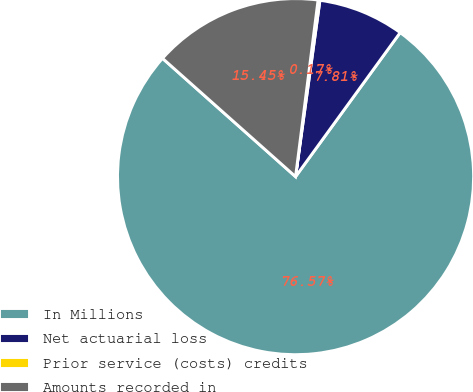Convert chart. <chart><loc_0><loc_0><loc_500><loc_500><pie_chart><fcel>In Millions<fcel>Net actuarial loss<fcel>Prior service (costs) credits<fcel>Amounts recorded in<nl><fcel>76.58%<fcel>7.81%<fcel>0.17%<fcel>15.45%<nl></chart> 